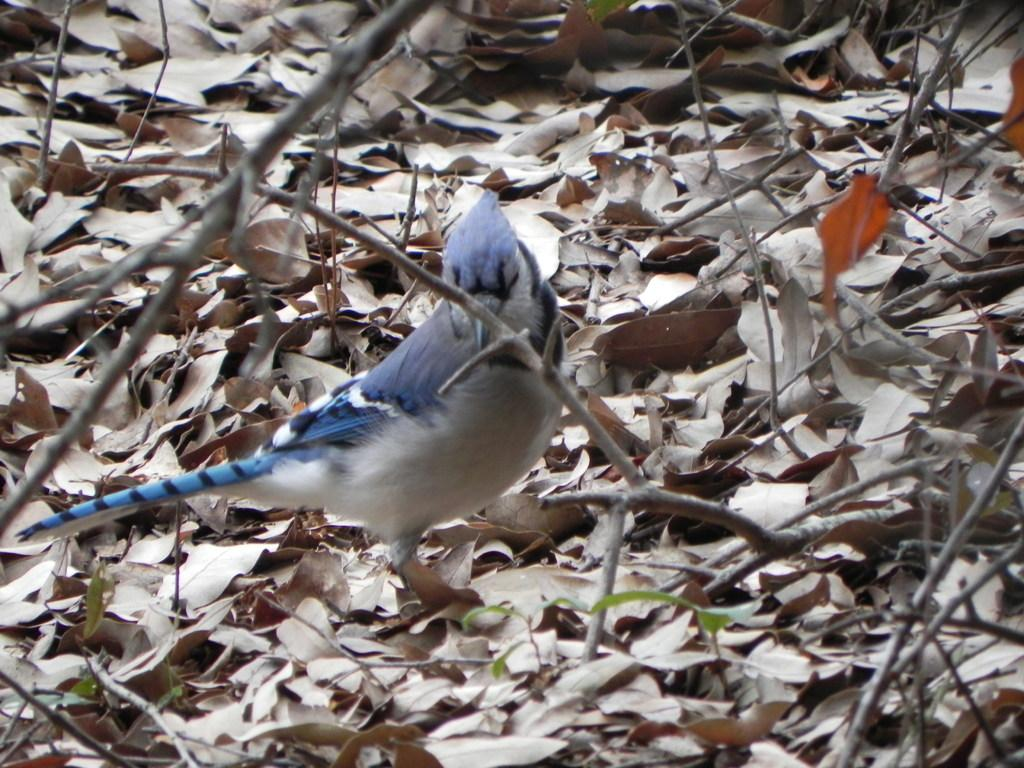What type of animal is present in the image? There is a bird in the image. What can be seen on the ground in the image? There are dry leaves and stems on the ground in the image. What is the bird's desire in the image? There is no indication of the bird's desires in the image, as it is a static representation. 